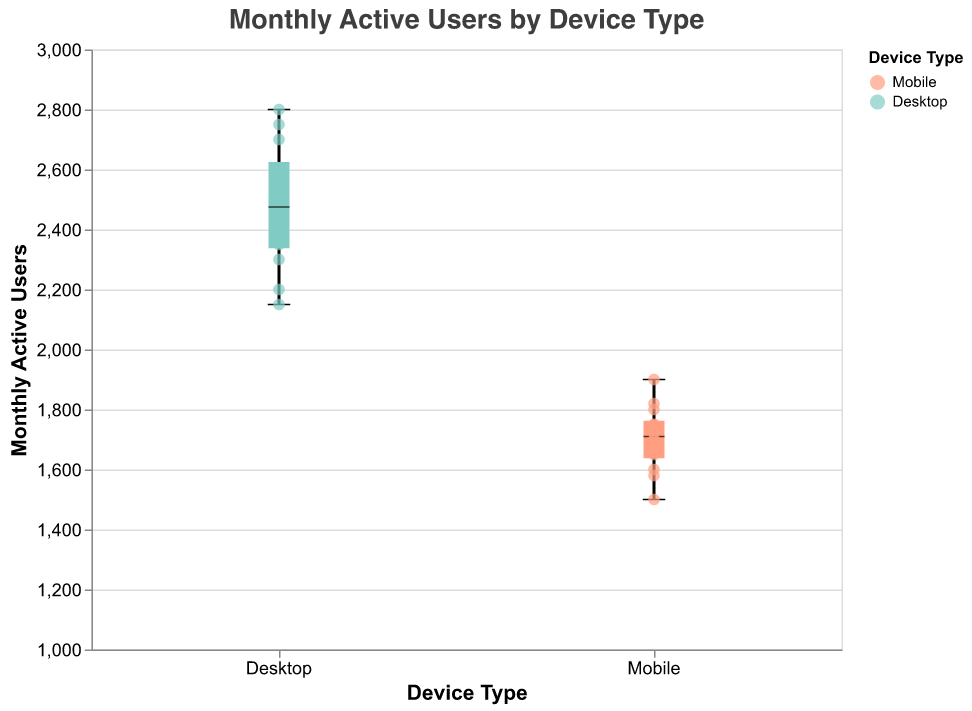What is the title of the plot? The title is displayed at the top of the plot reading "Monthly Active Users by Device Type."
Answer: Monthly Active Users by Device Type How many device types are displayed in the plot? The x-axis shows two device types: Mobile and Desktop.
Answer: 2 Which device type has greater median users in November? November has 1820 for Mobile and 2750 for Desktop. The median for Desktop in November is greater.
Answer: Desktop What's the overall trend of mobile user counts from January to December? Mobile user counts are increasing from January (1500) to December (1900).
Answer: Increasing What is the difference in the number of users between Desktop in December and Mobile in December? December values are 2800 for Desktop and 1900 for Mobile. Subtracting these gives 2800 - 1900 = 900.
Answer: 900 Which month had the highest number of Desktop users and how many? The highest Desktop user count occurs in November with 2750 users.
Answer: November, 2750 What is the average number of Mobile users from January to June? Sum January to June Mobile users: 1500 + 1580 + 1600 + 1700 + 1650 + 1750 = 9780. Divide by 6 months: 9780/6 = 1630.
Answer: 1630 How does the range of mobile users' data compare to that of desktop users? The range of Mobile users spans from 1500 to 1900, while Desktop users span from 2150 to 2800. Mobile range = 1900 - 1500 = 400, Desktop range = 2800 - 2150 = 650. Desktop has a wider range.
Answer: Desktop What is the median number of users for Mobile over the year? List monthly Mobile users: 1500, 1580, 1600, 1700, 1650, 1750, 1800, 1720, 1680, 1750, 1820, 1900. Median is middle value(s) of ordered data. Sorted: 1500, 1580, 1600, 1650, 1680, 1700, 1720, 1750, 1750, 1800, 1820, 1900. Median = (1700+1720)/2 = 1710.
Answer: 1710 